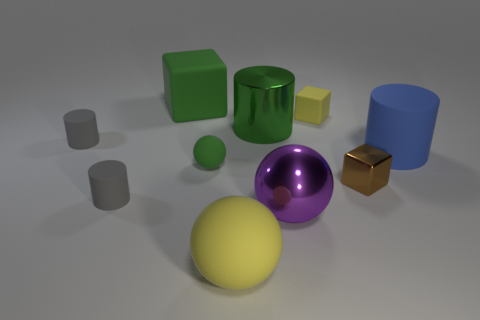What time of day and what kind of environment do you infer from the image? The image conveys an artificial or studio-style environment with neutral, probably indoor, lighting that looks like it's not influenced by any particular time of day. The uniform lighting and soft shadows suggest a controlled setting, likely designed to focus on the objects rather than convey a specific time or place. Is there any interaction between the objects? The objects do not appear to be interacting with one another; they are placed apart, suggesting no direct relationship or interaction. Their placement seems intentional, possibly for displaying contrast between shapes, sizes, colors, and textures, rather than depicting a narrative or dynamic interaction. 